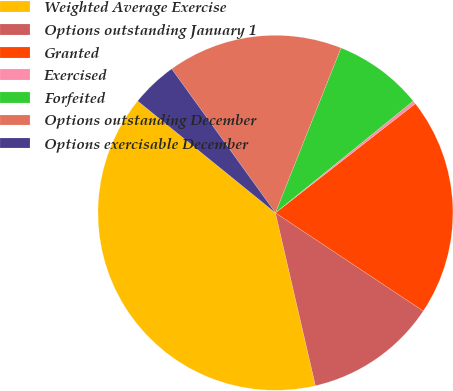Convert chart. <chart><loc_0><loc_0><loc_500><loc_500><pie_chart><fcel>Weighted Average Exercise<fcel>Options outstanding January 1<fcel>Granted<fcel>Exercised<fcel>Forfeited<fcel>Options outstanding December<fcel>Options exercisable December<nl><fcel>39.47%<fcel>12.05%<fcel>19.88%<fcel>0.3%<fcel>8.13%<fcel>15.96%<fcel>4.21%<nl></chart> 